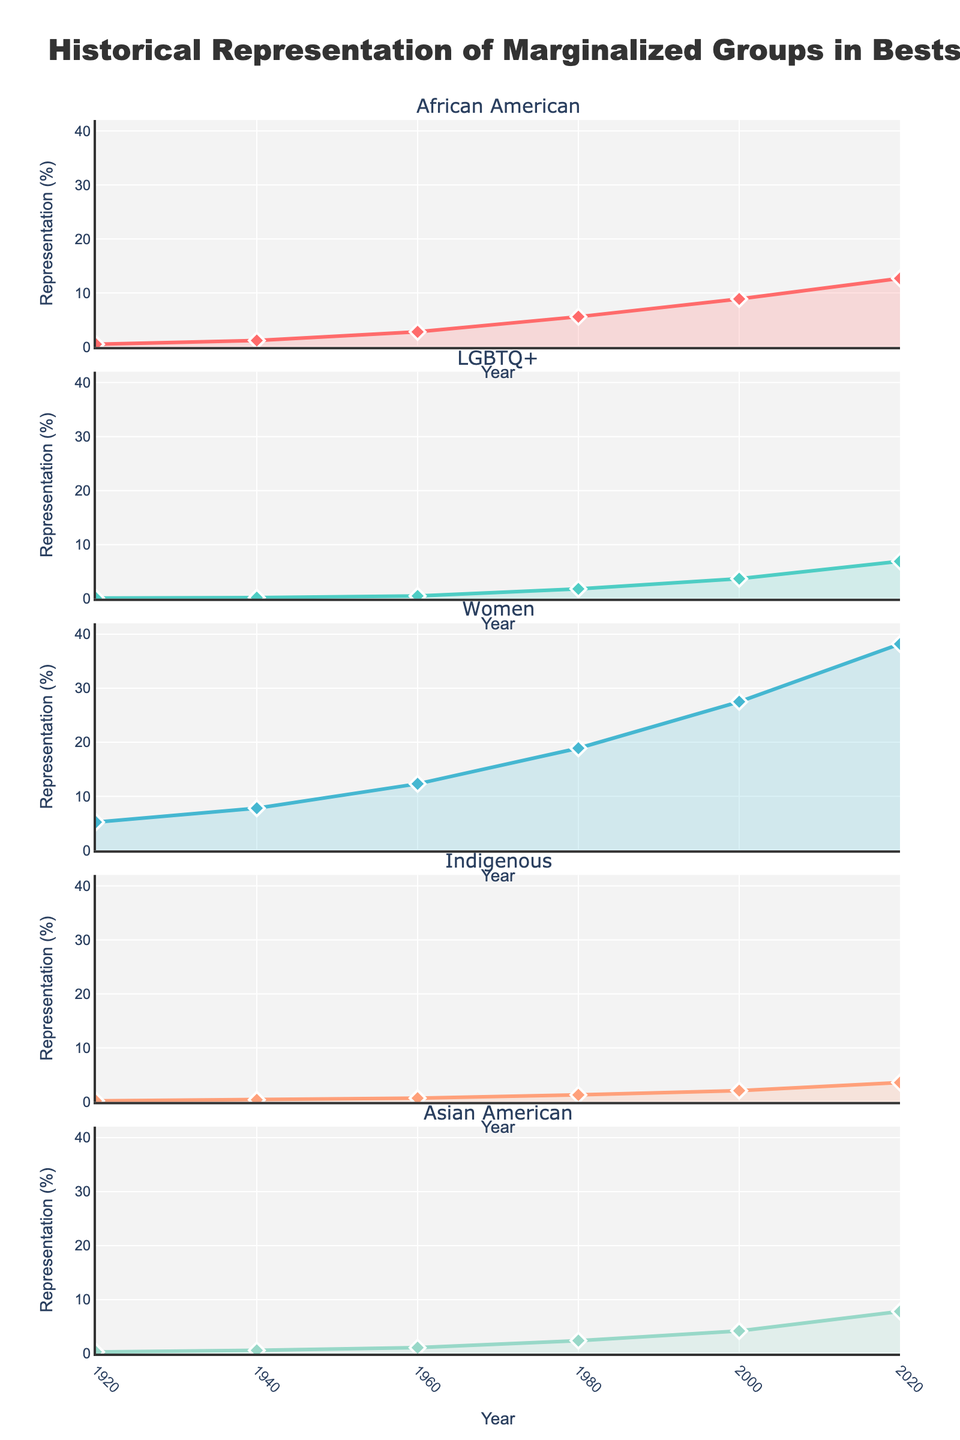what is the title of the figure? The title of the figure is located at the top and reads: "Historical Representation of Marginalized Groups in Bestselling Books"
Answer: Historical Representation of Marginalized Groups in Bestselling Books Which group had the highest representation in 2020? The subplot for 2020 shows the lines and markers. The group with the highest line and marker in 2020 is Women.
Answer: Women What is the trend of African American representation from 1920 to 2020? Observing the line for African American from 1920 to 2020, it starts at 0.5% in 1920 and gradually increases to 12.7% in 2020.
Answer: Increasing Which year shows the most diversity in representation among marginalized groups? The year 2020 shows the most diversity, as it has the highest representation percentages for all groups compared to previous years.
Answer: 2020 How has the representation of LGBTQ+ people changed from 1980 to 2000? The representation of LGBTQ+ people in 1980 is 1.8% and increases to 3.7% by 2000. This shows an increase of 1.9% over the 20-year period.
Answer: Increased by 1.9% Between which consecutive 20-year periods did the Indigenous representation grow the most? Comparing differences between 1920-1940, 1940-1960, 1960-1980, 1980-2000, and 2000-2020: The differences are 0.2%, 0.3%, 0.6%, 0.8%, and 1.5% respectively. The largest growth is between 2000 and 2020.
Answer: Between 2000-2020 How does the representation of Asian American stories change from 1940 to 1960? The representation goes from 0.6% in 1940 to 1.1% in 1960, so it increased by 0.5 percentage points.
Answer: Increased by 0.5% What's the average representation of Women in the years depicted? The percentages for Women are 5.2, 7.8, 12.3, 18.9, 27.5, and 38.2 across the six years. Summing these gives 110.9 and dividing by 6 gives an average of approximately 18.48%.
Answer: Approximately 18.48% By how much did African American representation grow between 1960 and 1980? In 1960 the representation was 2.8%, and it rose to 5.6% in 1980. The growth is therefore 5.6 - 2.8 = 2.8 percentage points.
Answer: 2.8 percentage points 